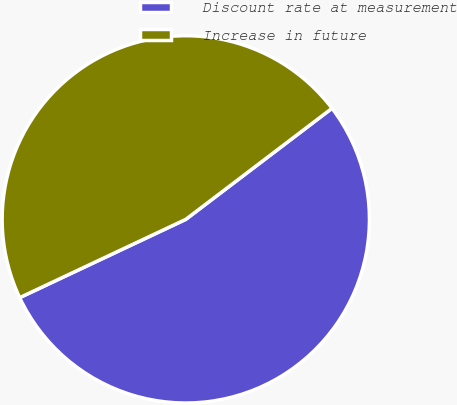Convert chart to OTSL. <chart><loc_0><loc_0><loc_500><loc_500><pie_chart><fcel>Discount rate at measurement<fcel>Increase in future<nl><fcel>53.33%<fcel>46.67%<nl></chart> 